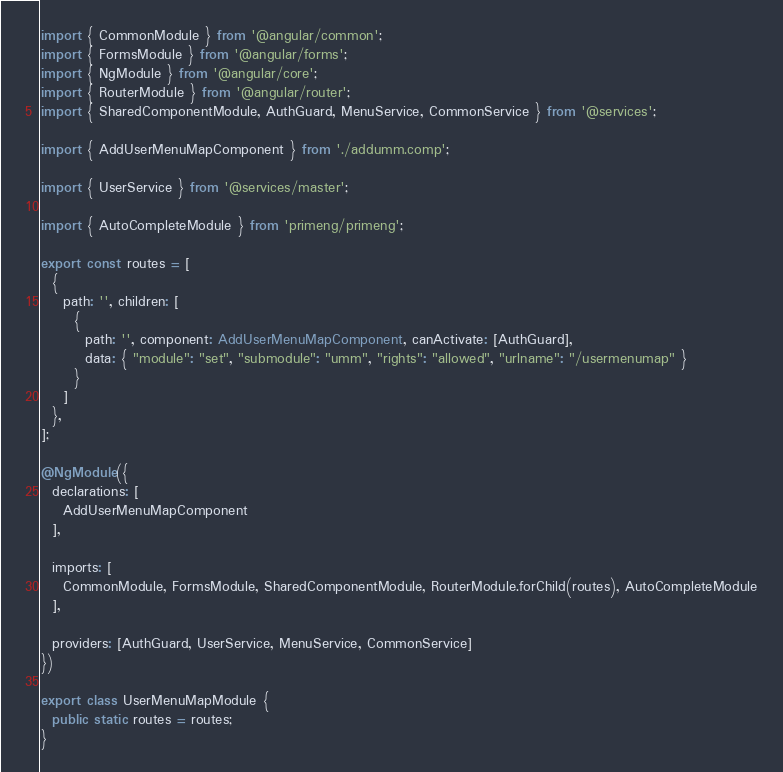Convert code to text. <code><loc_0><loc_0><loc_500><loc_500><_TypeScript_>import { CommonModule } from '@angular/common';
import { FormsModule } from '@angular/forms';
import { NgModule } from '@angular/core';
import { RouterModule } from '@angular/router';
import { SharedComponentModule, AuthGuard, MenuService, CommonService } from '@services';

import { AddUserMenuMapComponent } from './addumm.comp';

import { UserService } from '@services/master';

import { AutoCompleteModule } from 'primeng/primeng';

export const routes = [
  {
    path: '', children: [
      {
        path: '', component: AddUserMenuMapComponent, canActivate: [AuthGuard],
        data: { "module": "set", "submodule": "umm", "rights": "allowed", "urlname": "/usermenumap" }
      }
    ]
  },
];

@NgModule({
  declarations: [
    AddUserMenuMapComponent
  ],

  imports: [
    CommonModule, FormsModule, SharedComponentModule, RouterModule.forChild(routes), AutoCompleteModule
  ],

  providers: [AuthGuard, UserService, MenuService, CommonService]
})

export class UserMenuMapModule {
  public static routes = routes;
}
</code> 